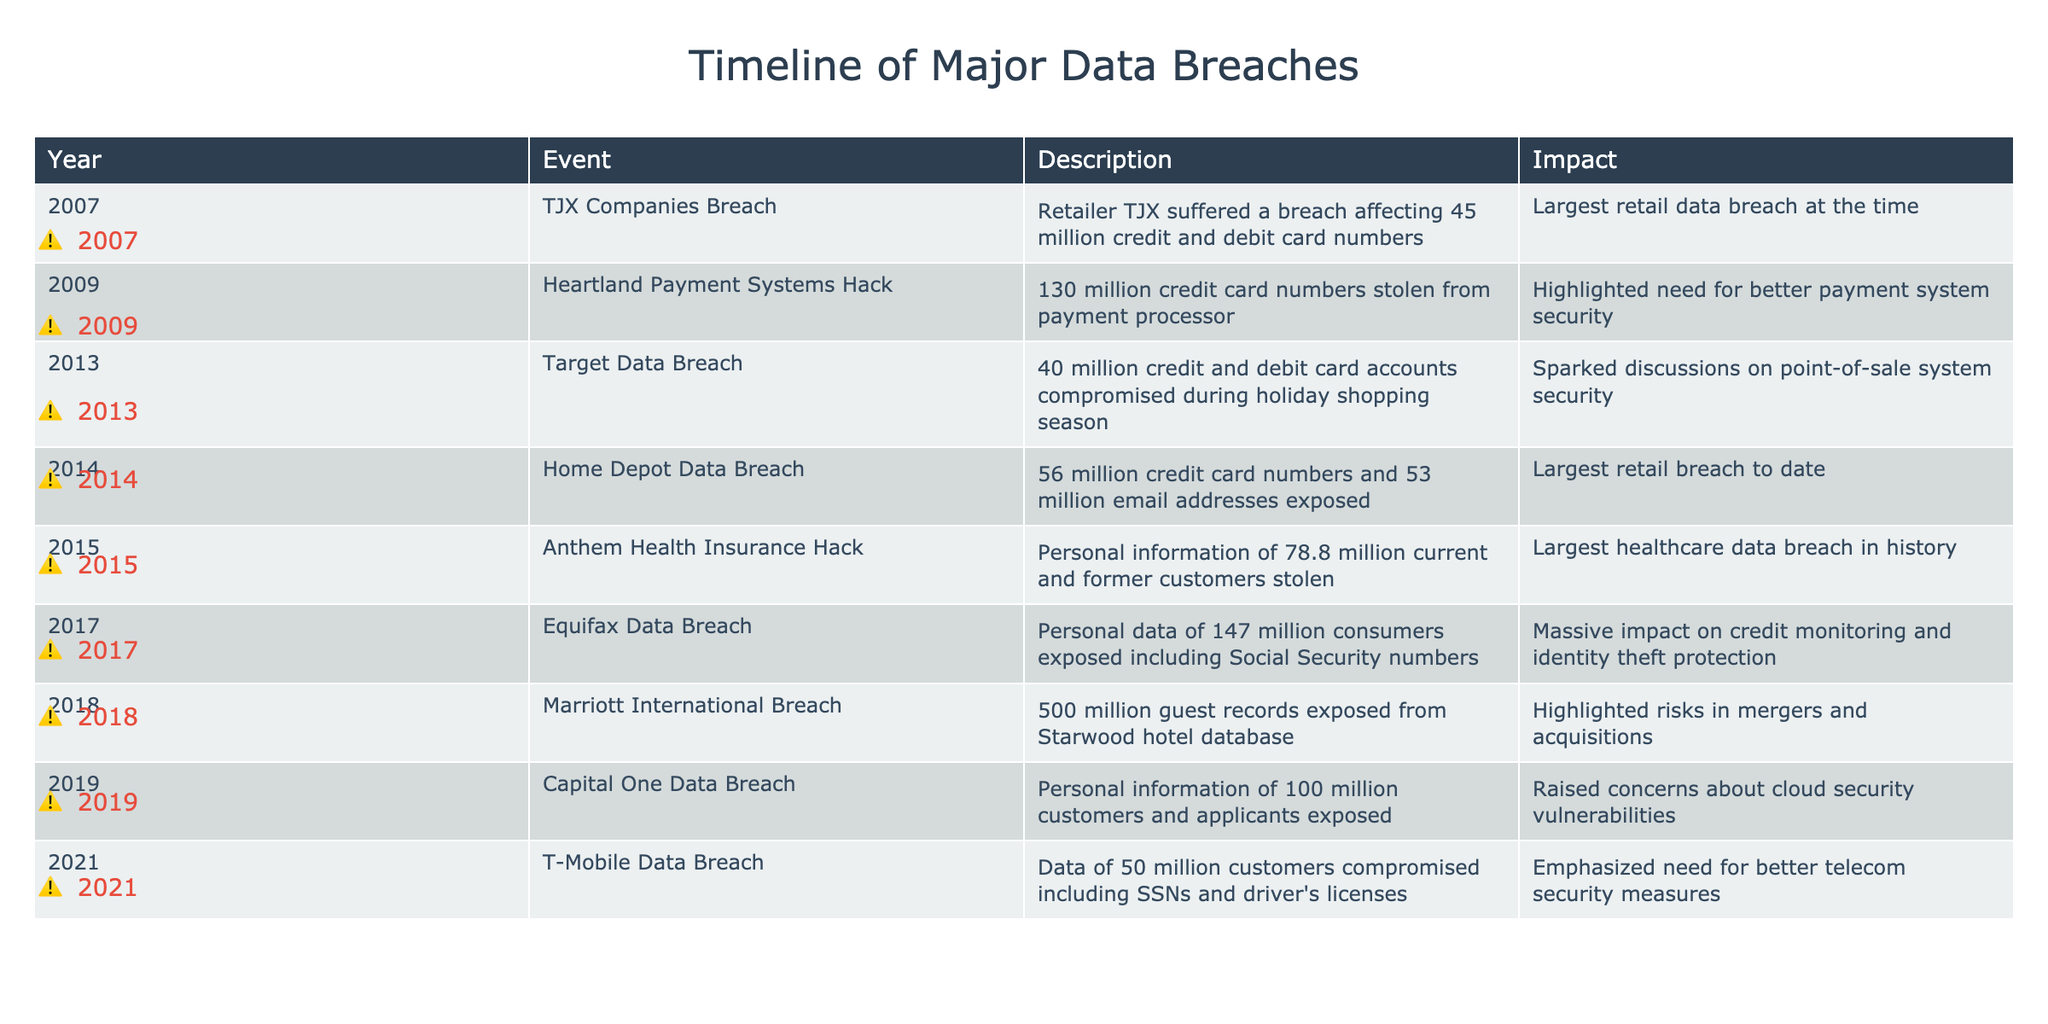What was the largest data breach according to the table? The table indicates that the Anthem Health Insurance Hack in 2015 was the largest data breach, affecting the personal information of 78.8 million current and former customers.
Answer: Anthem Health Insurance Hack in 2015 Which year had the most number of personal records compromised? The Equifax Data Breach in 2017 revealed personal data of 147 million consumers, which is the highest number compared to other breaches listed in the table.
Answer: 2017 with Equifax Data Breach How many data breaches occurred in the retail sector? According to the table, there are four entries related to the retail sector: TJX Companies Breach, Target Data Breach, Home Depot Data Breach, and Capital One Data Breach. Thus, there are 4 retail breaches.
Answer: 4 Was the Home Depot Data Breach larger or smaller than the Target Data Breach? The Home Depot Data Breach affected 56 million credit card numbers and email addresses, while the Target Data Breach involved 40 million accounts. Thus, Home Depot's breach was larger.
Answer: Larger What is the average number of records affected in major breaches from 2015 onwards? The breaches from 2015 onwards are Anthem Health Insurance with 78.8 million, Equifax with 147 million, Marriott with 500 million, and T-Mobile with 50 million. The total equals 775.8 million, and there are 4 breaches, so the average is 775.8 million / 4 = 193.95 million.
Answer: 193.95 million Did the 2014 Home Depot breach have a higher impact than the 2009 Heartland Payment Systems Hack? Yes, the Home Depot breach affected 56 million records while the Heartland Payment Systems Hack compromised 130 million records. Thus, based on numbers, the Heartland Payment Systems Hack had a higher impact.
Answer: Yes In how many years did breaches expose over 100 million records? The breaches that exposed over 100 million records are the Heartland Payment Systems Hack in 2009, Anthem Health Insurance Hack in 2015, Equifax Data Breach in 2017, and Marriott International Breach in 2018. There are 4 such years.
Answer: 4 Which year had the fewest records compromised, and what was the impact? The year 2013 had the fewest records compromised with 40 million in the Target Data Breach, which has been described as sparking discussions on point-of-sale system security.
Answer: 2013, Target Data Breach with 40 million records What type of breaches highlighted security vulnerabilities in their respective sectors? The 2014 Home Depot Data Breach raised questions on retail security; the 2017 Equifax breach emphasized credit monitoring vulnerabilities; and the 2019 Capital One breach highlighted cloud security vulnerabilities.
Answer: Three breaches: Home Depot, Equifax, and Capital One 